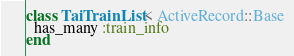<code> <loc_0><loc_0><loc_500><loc_500><_Ruby_>class TaiTrainList < ActiveRecord::Base
  has_many :train_info
end
</code> 